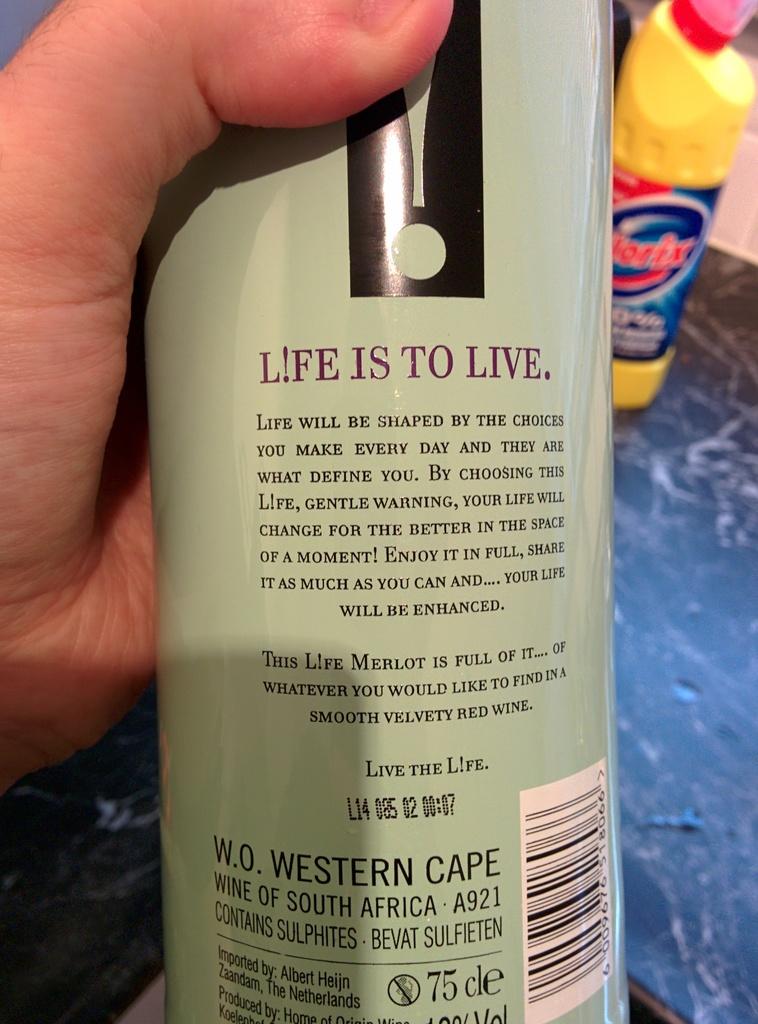What country is this wine from?
Your answer should be compact. South africa. First word on top?
Offer a very short reply. Life. 